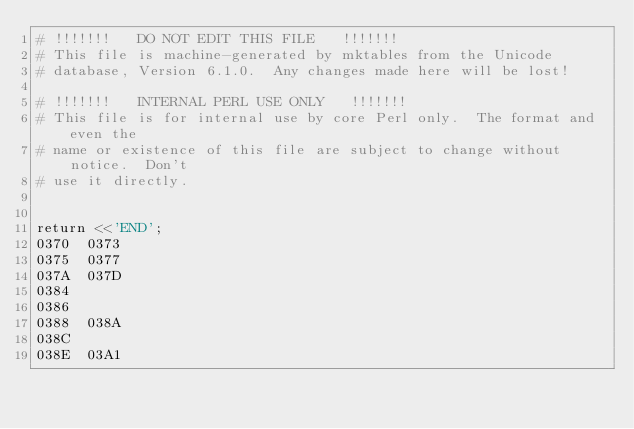Convert code to text. <code><loc_0><loc_0><loc_500><loc_500><_Perl_># !!!!!!!   DO NOT EDIT THIS FILE   !!!!!!!
# This file is machine-generated by mktables from the Unicode
# database, Version 6.1.0.  Any changes made here will be lost!

# !!!!!!!   INTERNAL PERL USE ONLY   !!!!!!!
# This file is for internal use by core Perl only.  The format and even the
# name or existence of this file are subject to change without notice.  Don't
# use it directly.


return <<'END';
0370	0373
0375	0377
037A	037D
0384		
0386		
0388	038A
038C		
038E	03A1</code> 